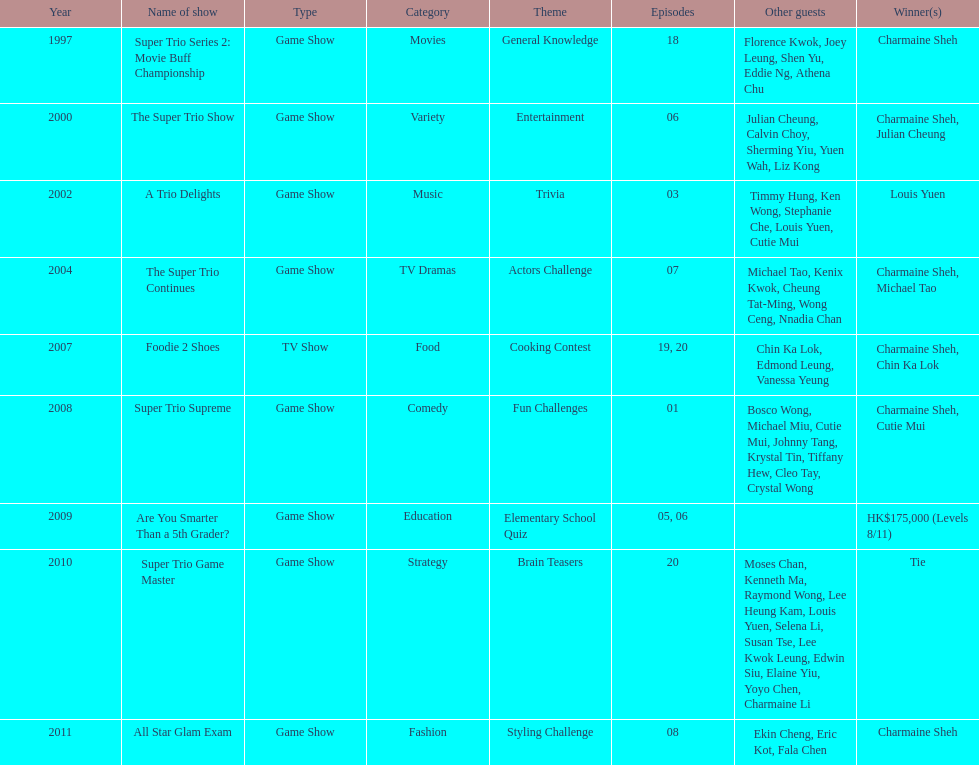How many consecutive trio shows did charmaine sheh do before being on another variety program? 34. 